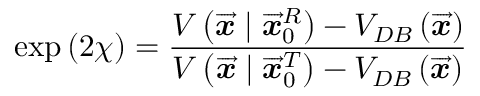<formula> <loc_0><loc_0><loc_500><loc_500>\exp \left ( 2 \chi \right ) = \frac { V \left ( \overrightarrow { \mathbf i t { x } } | \overrightarrow { \mathbf i t { x } } _ { 0 } ^ { R } \right ) - V _ { D B } \left ( \overrightarrow { \mathbf i t { x } } \right ) } { V \left ( \overrightarrow { \mathbf i t { x } } | \overrightarrow { \mathbf i t { x } } _ { 0 } ^ { T } \right ) - V _ { D B } \left ( \overrightarrow { \mathbf i t { x } } \right ) }</formula> 